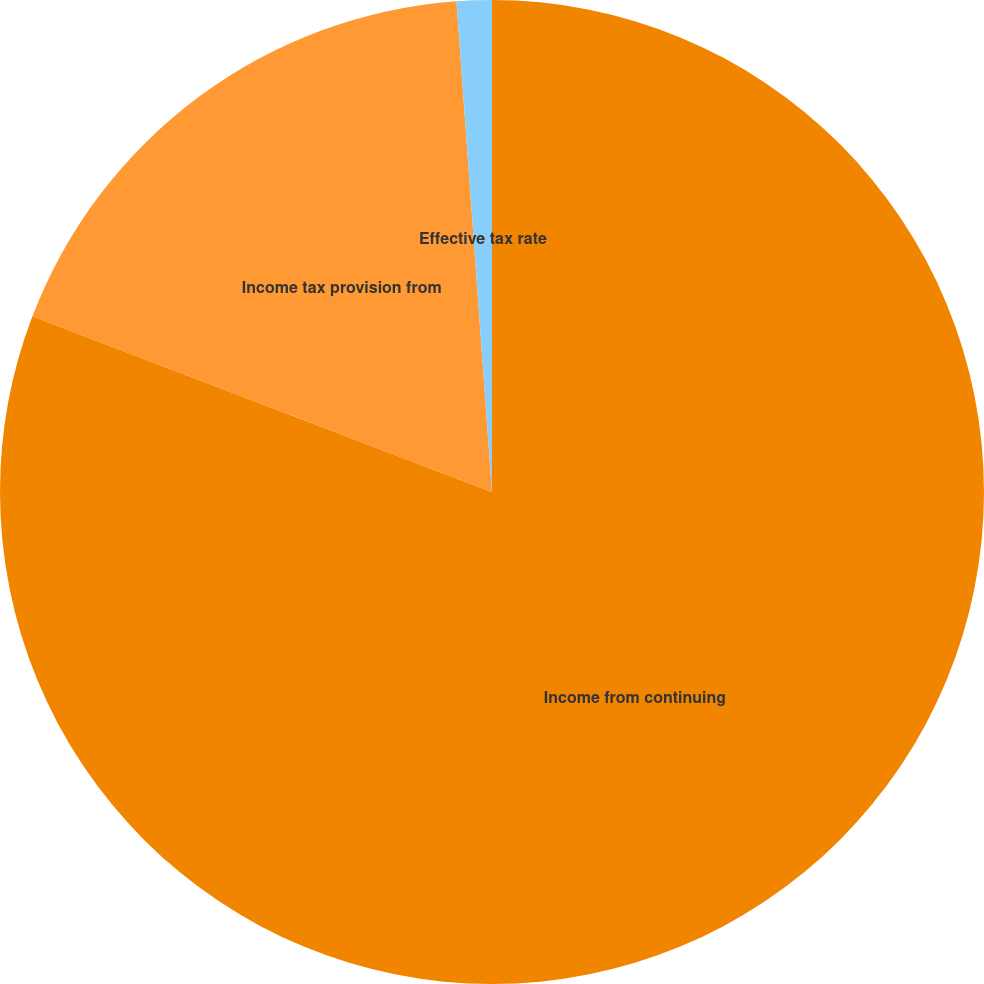Convert chart. <chart><loc_0><loc_0><loc_500><loc_500><pie_chart><fcel>Income from continuing<fcel>Income tax provision from<fcel>Effective tax rate<nl><fcel>80.81%<fcel>18.04%<fcel>1.15%<nl></chart> 